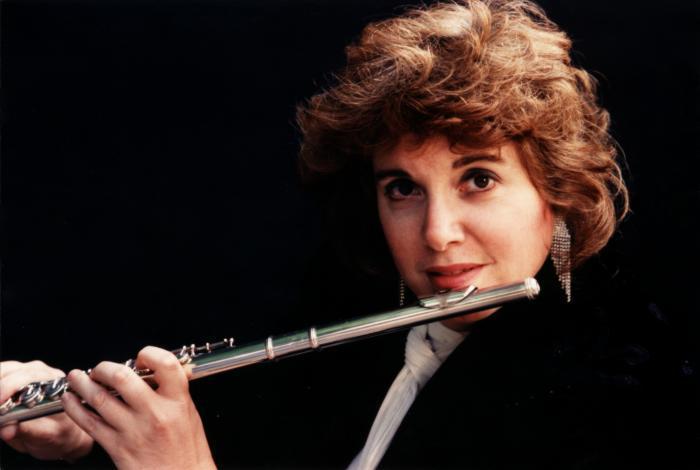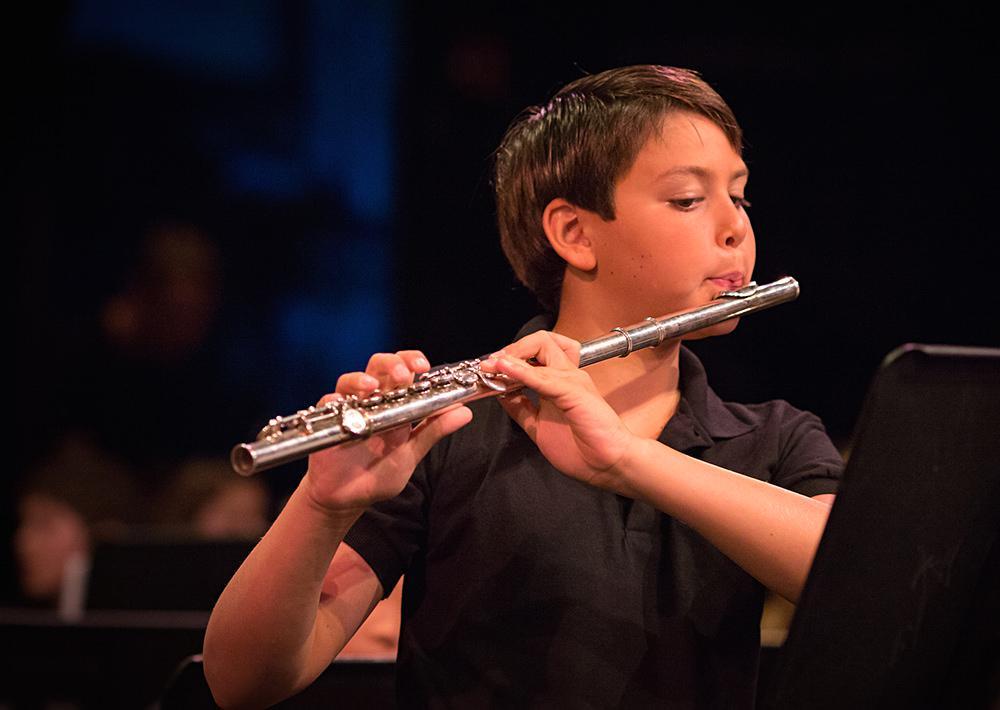The first image is the image on the left, the second image is the image on the right. Evaluate the accuracy of this statement regarding the images: "a man in a button down shirt with a striped banner on his shoulder is playing a wooden flute". Is it true? Answer yes or no. No. The first image is the image on the left, the second image is the image on the right. Assess this claim about the two images: "The left image contains a man in a red long sleeved shirt playing a musical instrument.". Correct or not? Answer yes or no. No. 